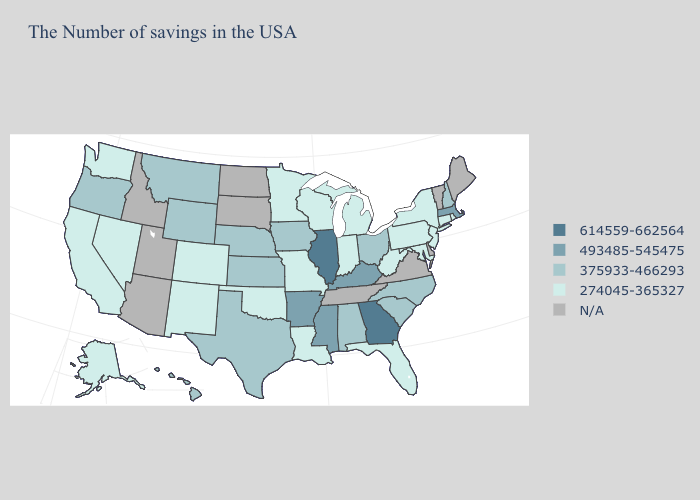Does Massachusetts have the highest value in the Northeast?
Keep it brief. Yes. Does Hawaii have the lowest value in the West?
Give a very brief answer. No. Which states have the lowest value in the MidWest?
Write a very short answer. Michigan, Indiana, Wisconsin, Missouri, Minnesota. What is the value of Illinois?
Answer briefly. 614559-662564. Name the states that have a value in the range 274045-365327?
Give a very brief answer. Rhode Island, Connecticut, New York, New Jersey, Maryland, Pennsylvania, West Virginia, Florida, Michigan, Indiana, Wisconsin, Louisiana, Missouri, Minnesota, Oklahoma, Colorado, New Mexico, Nevada, California, Washington, Alaska. Which states have the highest value in the USA?
Give a very brief answer. Georgia, Illinois. What is the value of New York?
Write a very short answer. 274045-365327. What is the value of Arkansas?
Quick response, please. 493485-545475. What is the value of Ohio?
Short answer required. 375933-466293. What is the lowest value in the West?
Quick response, please. 274045-365327. Name the states that have a value in the range 493485-545475?
Be succinct. Massachusetts, Kentucky, Mississippi, Arkansas. Is the legend a continuous bar?
Keep it brief. No. Name the states that have a value in the range N/A?
Short answer required. Maine, Vermont, Delaware, Virginia, Tennessee, South Dakota, North Dakota, Utah, Arizona, Idaho. Name the states that have a value in the range N/A?
Concise answer only. Maine, Vermont, Delaware, Virginia, Tennessee, South Dakota, North Dakota, Utah, Arizona, Idaho. What is the value of Louisiana?
Write a very short answer. 274045-365327. 